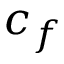Convert formula to latex. <formula><loc_0><loc_0><loc_500><loc_500>c _ { f }</formula> 